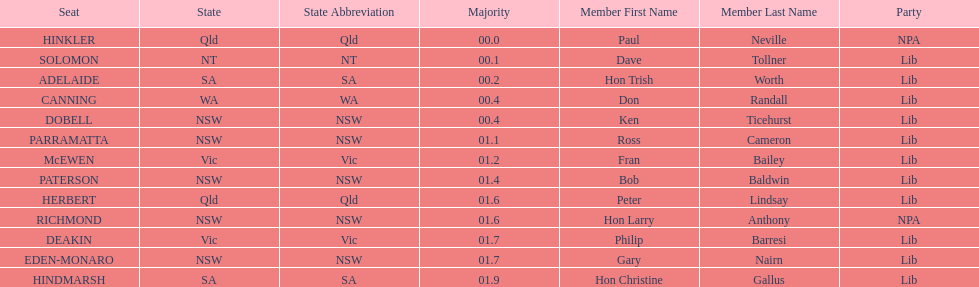Could you parse the entire table? {'header': ['Seat', 'State', 'State Abbreviation', 'Majority', 'Member First Name', 'Member Last Name', 'Party'], 'rows': [['HINKLER', 'Qld', 'Qld', '00.0', 'Paul', 'Neville', 'NPA'], ['SOLOMON', 'NT', 'NT', '00.1', 'Dave', 'Tollner', 'Lib'], ['ADELAIDE', 'SA', 'SA', '00.2', 'Hon Trish', 'Worth', 'Lib'], ['CANNING', 'WA', 'WA', '00.4', 'Don', 'Randall', 'Lib'], ['DOBELL', 'NSW', 'NSW', '00.4', 'Ken', 'Ticehurst', 'Lib'], ['PARRAMATTA', 'NSW', 'NSW', '01.1', 'Ross', 'Cameron', 'Lib'], ['McEWEN', 'Vic', 'Vic', '01.2', 'Fran', 'Bailey', 'Lib'], ['PATERSON', 'NSW', 'NSW', '01.4', 'Bob', 'Baldwin', 'Lib'], ['HERBERT', 'Qld', 'Qld', '01.6', 'Peter', 'Lindsay', 'Lib'], ['RICHMOND', 'NSW', 'NSW', '01.6', 'Hon Larry', 'Anthony', 'NPA'], ['DEAKIN', 'Vic', 'Vic', '01.7', 'Philip', 'Barresi', 'Lib'], ['EDEN-MONARO', 'NSW', 'NSW', '01.7', 'Gary', 'Nairn', 'Lib'], ['HINDMARSH', 'SA', 'SA', '01.9', 'Hon Christine', 'Gallus', 'Lib']]} Who is listed before don randall? Hon Trish Worth. 